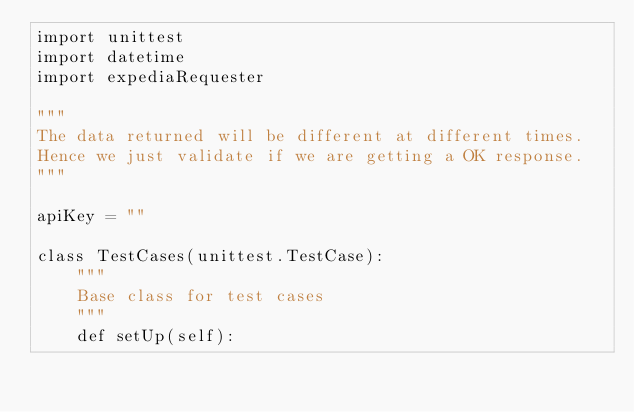Convert code to text. <code><loc_0><loc_0><loc_500><loc_500><_Python_>import unittest
import datetime
import expediaRequester

"""
The data returned will be different at different times.
Hence we just validate if we are getting a OK response.
"""

apiKey = ""

class TestCases(unittest.TestCase):
    """
    Base class for test cases
    """
    def setUp(self):</code> 